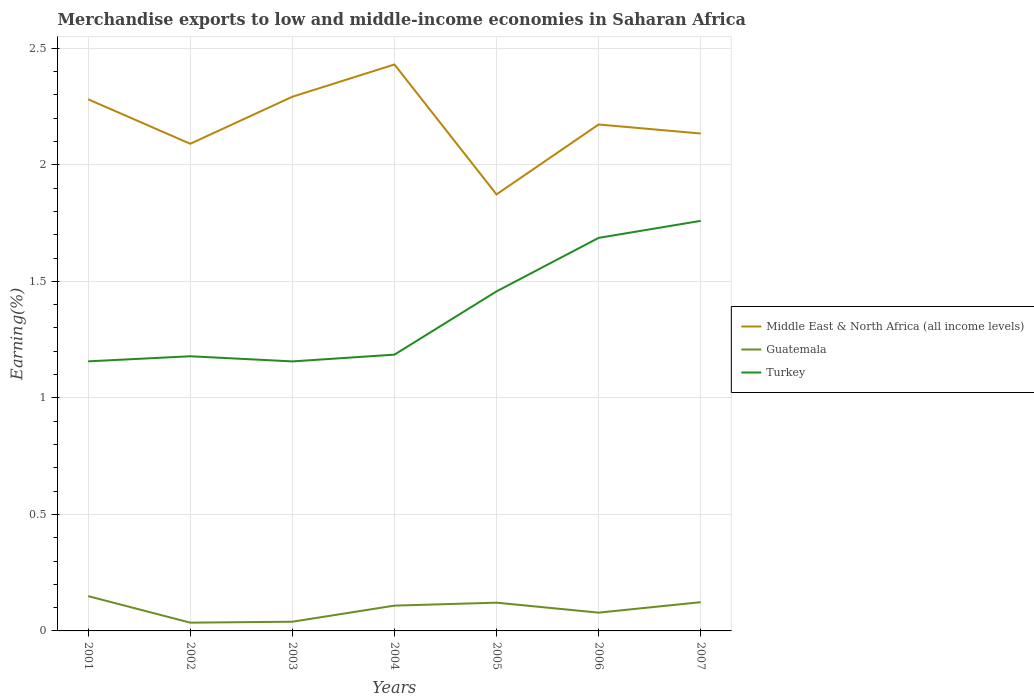Across all years, what is the maximum percentage of amount earned from merchandise exports in Guatemala?
Provide a short and direct response. 0.04. In which year was the percentage of amount earned from merchandise exports in Middle East & North Africa (all income levels) maximum?
Provide a succinct answer. 2005. What is the total percentage of amount earned from merchandise exports in Turkey in the graph?
Provide a short and direct response. 0. What is the difference between the highest and the second highest percentage of amount earned from merchandise exports in Middle East & North Africa (all income levels)?
Offer a terse response. 0.56. What is the difference between the highest and the lowest percentage of amount earned from merchandise exports in Guatemala?
Make the answer very short. 4. Is the percentage of amount earned from merchandise exports in Turkey strictly greater than the percentage of amount earned from merchandise exports in Guatemala over the years?
Your response must be concise. No. How many years are there in the graph?
Provide a succinct answer. 7. Does the graph contain any zero values?
Your response must be concise. No. What is the title of the graph?
Your answer should be very brief. Merchandise exports to low and middle-income economies in Saharan Africa. Does "Iran" appear as one of the legend labels in the graph?
Offer a very short reply. No. What is the label or title of the Y-axis?
Provide a short and direct response. Earning(%). What is the Earning(%) of Middle East & North Africa (all income levels) in 2001?
Your answer should be compact. 2.28. What is the Earning(%) in Guatemala in 2001?
Make the answer very short. 0.15. What is the Earning(%) of Turkey in 2001?
Make the answer very short. 1.16. What is the Earning(%) of Middle East & North Africa (all income levels) in 2002?
Ensure brevity in your answer.  2.09. What is the Earning(%) of Guatemala in 2002?
Make the answer very short. 0.04. What is the Earning(%) in Turkey in 2002?
Ensure brevity in your answer.  1.18. What is the Earning(%) in Middle East & North Africa (all income levels) in 2003?
Offer a terse response. 2.29. What is the Earning(%) in Guatemala in 2003?
Your answer should be compact. 0.04. What is the Earning(%) of Turkey in 2003?
Your answer should be very brief. 1.16. What is the Earning(%) in Middle East & North Africa (all income levels) in 2004?
Your response must be concise. 2.43. What is the Earning(%) in Guatemala in 2004?
Give a very brief answer. 0.11. What is the Earning(%) of Turkey in 2004?
Provide a succinct answer. 1.19. What is the Earning(%) of Middle East & North Africa (all income levels) in 2005?
Offer a terse response. 1.87. What is the Earning(%) of Guatemala in 2005?
Ensure brevity in your answer.  0.12. What is the Earning(%) of Turkey in 2005?
Give a very brief answer. 1.46. What is the Earning(%) in Middle East & North Africa (all income levels) in 2006?
Ensure brevity in your answer.  2.17. What is the Earning(%) of Guatemala in 2006?
Your answer should be compact. 0.08. What is the Earning(%) in Turkey in 2006?
Offer a very short reply. 1.69. What is the Earning(%) of Middle East & North Africa (all income levels) in 2007?
Your answer should be very brief. 2.13. What is the Earning(%) of Guatemala in 2007?
Your response must be concise. 0.12. What is the Earning(%) of Turkey in 2007?
Your answer should be very brief. 1.76. Across all years, what is the maximum Earning(%) of Middle East & North Africa (all income levels)?
Your answer should be compact. 2.43. Across all years, what is the maximum Earning(%) of Guatemala?
Give a very brief answer. 0.15. Across all years, what is the maximum Earning(%) in Turkey?
Give a very brief answer. 1.76. Across all years, what is the minimum Earning(%) of Middle East & North Africa (all income levels)?
Provide a short and direct response. 1.87. Across all years, what is the minimum Earning(%) of Guatemala?
Make the answer very short. 0.04. Across all years, what is the minimum Earning(%) in Turkey?
Your answer should be compact. 1.16. What is the total Earning(%) in Middle East & North Africa (all income levels) in the graph?
Ensure brevity in your answer.  15.27. What is the total Earning(%) in Guatemala in the graph?
Provide a succinct answer. 0.66. What is the total Earning(%) of Turkey in the graph?
Your answer should be very brief. 9.58. What is the difference between the Earning(%) in Middle East & North Africa (all income levels) in 2001 and that in 2002?
Make the answer very short. 0.19. What is the difference between the Earning(%) of Guatemala in 2001 and that in 2002?
Give a very brief answer. 0.11. What is the difference between the Earning(%) in Turkey in 2001 and that in 2002?
Keep it short and to the point. -0.02. What is the difference between the Earning(%) of Middle East & North Africa (all income levels) in 2001 and that in 2003?
Your answer should be compact. -0.01. What is the difference between the Earning(%) in Guatemala in 2001 and that in 2003?
Your response must be concise. 0.11. What is the difference between the Earning(%) in Turkey in 2001 and that in 2003?
Ensure brevity in your answer.  0. What is the difference between the Earning(%) of Middle East & North Africa (all income levels) in 2001 and that in 2004?
Make the answer very short. -0.15. What is the difference between the Earning(%) of Guatemala in 2001 and that in 2004?
Offer a very short reply. 0.04. What is the difference between the Earning(%) of Turkey in 2001 and that in 2004?
Give a very brief answer. -0.03. What is the difference between the Earning(%) of Middle East & North Africa (all income levels) in 2001 and that in 2005?
Make the answer very short. 0.41. What is the difference between the Earning(%) of Guatemala in 2001 and that in 2005?
Provide a succinct answer. 0.03. What is the difference between the Earning(%) in Turkey in 2001 and that in 2005?
Ensure brevity in your answer.  -0.3. What is the difference between the Earning(%) of Middle East & North Africa (all income levels) in 2001 and that in 2006?
Your answer should be very brief. 0.11. What is the difference between the Earning(%) in Guatemala in 2001 and that in 2006?
Provide a short and direct response. 0.07. What is the difference between the Earning(%) in Turkey in 2001 and that in 2006?
Your response must be concise. -0.53. What is the difference between the Earning(%) of Middle East & North Africa (all income levels) in 2001 and that in 2007?
Give a very brief answer. 0.15. What is the difference between the Earning(%) in Guatemala in 2001 and that in 2007?
Your response must be concise. 0.03. What is the difference between the Earning(%) in Turkey in 2001 and that in 2007?
Keep it short and to the point. -0.6. What is the difference between the Earning(%) of Middle East & North Africa (all income levels) in 2002 and that in 2003?
Provide a succinct answer. -0.2. What is the difference between the Earning(%) in Guatemala in 2002 and that in 2003?
Keep it short and to the point. -0. What is the difference between the Earning(%) in Turkey in 2002 and that in 2003?
Offer a terse response. 0.02. What is the difference between the Earning(%) of Middle East & North Africa (all income levels) in 2002 and that in 2004?
Keep it short and to the point. -0.34. What is the difference between the Earning(%) of Guatemala in 2002 and that in 2004?
Keep it short and to the point. -0.07. What is the difference between the Earning(%) in Turkey in 2002 and that in 2004?
Your response must be concise. -0.01. What is the difference between the Earning(%) of Middle East & North Africa (all income levels) in 2002 and that in 2005?
Give a very brief answer. 0.22. What is the difference between the Earning(%) of Guatemala in 2002 and that in 2005?
Keep it short and to the point. -0.09. What is the difference between the Earning(%) in Turkey in 2002 and that in 2005?
Ensure brevity in your answer.  -0.28. What is the difference between the Earning(%) in Middle East & North Africa (all income levels) in 2002 and that in 2006?
Give a very brief answer. -0.08. What is the difference between the Earning(%) of Guatemala in 2002 and that in 2006?
Your answer should be very brief. -0.04. What is the difference between the Earning(%) of Turkey in 2002 and that in 2006?
Keep it short and to the point. -0.51. What is the difference between the Earning(%) of Middle East & North Africa (all income levels) in 2002 and that in 2007?
Keep it short and to the point. -0.04. What is the difference between the Earning(%) in Guatemala in 2002 and that in 2007?
Keep it short and to the point. -0.09. What is the difference between the Earning(%) in Turkey in 2002 and that in 2007?
Provide a short and direct response. -0.58. What is the difference between the Earning(%) in Middle East & North Africa (all income levels) in 2003 and that in 2004?
Give a very brief answer. -0.14. What is the difference between the Earning(%) of Guatemala in 2003 and that in 2004?
Offer a very short reply. -0.07. What is the difference between the Earning(%) in Turkey in 2003 and that in 2004?
Give a very brief answer. -0.03. What is the difference between the Earning(%) of Middle East & North Africa (all income levels) in 2003 and that in 2005?
Provide a succinct answer. 0.42. What is the difference between the Earning(%) of Guatemala in 2003 and that in 2005?
Keep it short and to the point. -0.08. What is the difference between the Earning(%) in Turkey in 2003 and that in 2005?
Make the answer very short. -0.3. What is the difference between the Earning(%) of Middle East & North Africa (all income levels) in 2003 and that in 2006?
Make the answer very short. 0.12. What is the difference between the Earning(%) of Guatemala in 2003 and that in 2006?
Make the answer very short. -0.04. What is the difference between the Earning(%) in Turkey in 2003 and that in 2006?
Your answer should be compact. -0.53. What is the difference between the Earning(%) in Middle East & North Africa (all income levels) in 2003 and that in 2007?
Keep it short and to the point. 0.16. What is the difference between the Earning(%) in Guatemala in 2003 and that in 2007?
Keep it short and to the point. -0.08. What is the difference between the Earning(%) in Turkey in 2003 and that in 2007?
Offer a very short reply. -0.6. What is the difference between the Earning(%) of Middle East & North Africa (all income levels) in 2004 and that in 2005?
Keep it short and to the point. 0.56. What is the difference between the Earning(%) in Guatemala in 2004 and that in 2005?
Your answer should be compact. -0.01. What is the difference between the Earning(%) of Turkey in 2004 and that in 2005?
Ensure brevity in your answer.  -0.27. What is the difference between the Earning(%) of Middle East & North Africa (all income levels) in 2004 and that in 2006?
Ensure brevity in your answer.  0.26. What is the difference between the Earning(%) in Guatemala in 2004 and that in 2006?
Offer a terse response. 0.03. What is the difference between the Earning(%) in Turkey in 2004 and that in 2006?
Provide a short and direct response. -0.5. What is the difference between the Earning(%) of Middle East & North Africa (all income levels) in 2004 and that in 2007?
Ensure brevity in your answer.  0.3. What is the difference between the Earning(%) in Guatemala in 2004 and that in 2007?
Give a very brief answer. -0.01. What is the difference between the Earning(%) of Turkey in 2004 and that in 2007?
Keep it short and to the point. -0.57. What is the difference between the Earning(%) of Middle East & North Africa (all income levels) in 2005 and that in 2006?
Your response must be concise. -0.3. What is the difference between the Earning(%) in Guatemala in 2005 and that in 2006?
Offer a terse response. 0.04. What is the difference between the Earning(%) of Turkey in 2005 and that in 2006?
Provide a short and direct response. -0.23. What is the difference between the Earning(%) of Middle East & North Africa (all income levels) in 2005 and that in 2007?
Offer a terse response. -0.26. What is the difference between the Earning(%) of Guatemala in 2005 and that in 2007?
Offer a very short reply. -0. What is the difference between the Earning(%) of Turkey in 2005 and that in 2007?
Offer a terse response. -0.3. What is the difference between the Earning(%) of Middle East & North Africa (all income levels) in 2006 and that in 2007?
Keep it short and to the point. 0.04. What is the difference between the Earning(%) in Guatemala in 2006 and that in 2007?
Provide a short and direct response. -0.04. What is the difference between the Earning(%) in Turkey in 2006 and that in 2007?
Your answer should be compact. -0.07. What is the difference between the Earning(%) of Middle East & North Africa (all income levels) in 2001 and the Earning(%) of Guatemala in 2002?
Your response must be concise. 2.25. What is the difference between the Earning(%) in Middle East & North Africa (all income levels) in 2001 and the Earning(%) in Turkey in 2002?
Offer a terse response. 1.1. What is the difference between the Earning(%) of Guatemala in 2001 and the Earning(%) of Turkey in 2002?
Ensure brevity in your answer.  -1.03. What is the difference between the Earning(%) of Middle East & North Africa (all income levels) in 2001 and the Earning(%) of Guatemala in 2003?
Keep it short and to the point. 2.24. What is the difference between the Earning(%) of Middle East & North Africa (all income levels) in 2001 and the Earning(%) of Turkey in 2003?
Offer a terse response. 1.12. What is the difference between the Earning(%) in Guatemala in 2001 and the Earning(%) in Turkey in 2003?
Provide a short and direct response. -1.01. What is the difference between the Earning(%) of Middle East & North Africa (all income levels) in 2001 and the Earning(%) of Guatemala in 2004?
Give a very brief answer. 2.17. What is the difference between the Earning(%) in Middle East & North Africa (all income levels) in 2001 and the Earning(%) in Turkey in 2004?
Your answer should be compact. 1.1. What is the difference between the Earning(%) in Guatemala in 2001 and the Earning(%) in Turkey in 2004?
Offer a very short reply. -1.04. What is the difference between the Earning(%) in Middle East & North Africa (all income levels) in 2001 and the Earning(%) in Guatemala in 2005?
Provide a short and direct response. 2.16. What is the difference between the Earning(%) of Middle East & North Africa (all income levels) in 2001 and the Earning(%) of Turkey in 2005?
Offer a very short reply. 0.82. What is the difference between the Earning(%) of Guatemala in 2001 and the Earning(%) of Turkey in 2005?
Your answer should be compact. -1.31. What is the difference between the Earning(%) of Middle East & North Africa (all income levels) in 2001 and the Earning(%) of Guatemala in 2006?
Make the answer very short. 2.2. What is the difference between the Earning(%) in Middle East & North Africa (all income levels) in 2001 and the Earning(%) in Turkey in 2006?
Your answer should be compact. 0.59. What is the difference between the Earning(%) in Guatemala in 2001 and the Earning(%) in Turkey in 2006?
Ensure brevity in your answer.  -1.54. What is the difference between the Earning(%) in Middle East & North Africa (all income levels) in 2001 and the Earning(%) in Guatemala in 2007?
Give a very brief answer. 2.16. What is the difference between the Earning(%) of Middle East & North Africa (all income levels) in 2001 and the Earning(%) of Turkey in 2007?
Your response must be concise. 0.52. What is the difference between the Earning(%) in Guatemala in 2001 and the Earning(%) in Turkey in 2007?
Offer a very short reply. -1.61. What is the difference between the Earning(%) in Middle East & North Africa (all income levels) in 2002 and the Earning(%) in Guatemala in 2003?
Offer a very short reply. 2.05. What is the difference between the Earning(%) of Middle East & North Africa (all income levels) in 2002 and the Earning(%) of Turkey in 2003?
Give a very brief answer. 0.93. What is the difference between the Earning(%) of Guatemala in 2002 and the Earning(%) of Turkey in 2003?
Provide a short and direct response. -1.12. What is the difference between the Earning(%) of Middle East & North Africa (all income levels) in 2002 and the Earning(%) of Guatemala in 2004?
Make the answer very short. 1.98. What is the difference between the Earning(%) in Middle East & North Africa (all income levels) in 2002 and the Earning(%) in Turkey in 2004?
Provide a succinct answer. 0.9. What is the difference between the Earning(%) of Guatemala in 2002 and the Earning(%) of Turkey in 2004?
Keep it short and to the point. -1.15. What is the difference between the Earning(%) of Middle East & North Africa (all income levels) in 2002 and the Earning(%) of Guatemala in 2005?
Your response must be concise. 1.97. What is the difference between the Earning(%) of Middle East & North Africa (all income levels) in 2002 and the Earning(%) of Turkey in 2005?
Offer a terse response. 0.63. What is the difference between the Earning(%) of Guatemala in 2002 and the Earning(%) of Turkey in 2005?
Ensure brevity in your answer.  -1.42. What is the difference between the Earning(%) of Middle East & North Africa (all income levels) in 2002 and the Earning(%) of Guatemala in 2006?
Make the answer very short. 2.01. What is the difference between the Earning(%) in Middle East & North Africa (all income levels) in 2002 and the Earning(%) in Turkey in 2006?
Your answer should be very brief. 0.4. What is the difference between the Earning(%) in Guatemala in 2002 and the Earning(%) in Turkey in 2006?
Keep it short and to the point. -1.65. What is the difference between the Earning(%) of Middle East & North Africa (all income levels) in 2002 and the Earning(%) of Guatemala in 2007?
Provide a short and direct response. 1.97. What is the difference between the Earning(%) in Middle East & North Africa (all income levels) in 2002 and the Earning(%) in Turkey in 2007?
Offer a very short reply. 0.33. What is the difference between the Earning(%) of Guatemala in 2002 and the Earning(%) of Turkey in 2007?
Your answer should be very brief. -1.72. What is the difference between the Earning(%) of Middle East & North Africa (all income levels) in 2003 and the Earning(%) of Guatemala in 2004?
Your response must be concise. 2.18. What is the difference between the Earning(%) of Middle East & North Africa (all income levels) in 2003 and the Earning(%) of Turkey in 2004?
Ensure brevity in your answer.  1.11. What is the difference between the Earning(%) of Guatemala in 2003 and the Earning(%) of Turkey in 2004?
Offer a very short reply. -1.15. What is the difference between the Earning(%) in Middle East & North Africa (all income levels) in 2003 and the Earning(%) in Guatemala in 2005?
Offer a terse response. 2.17. What is the difference between the Earning(%) of Middle East & North Africa (all income levels) in 2003 and the Earning(%) of Turkey in 2005?
Offer a very short reply. 0.84. What is the difference between the Earning(%) of Guatemala in 2003 and the Earning(%) of Turkey in 2005?
Your answer should be compact. -1.42. What is the difference between the Earning(%) of Middle East & North Africa (all income levels) in 2003 and the Earning(%) of Guatemala in 2006?
Offer a very short reply. 2.21. What is the difference between the Earning(%) of Middle East & North Africa (all income levels) in 2003 and the Earning(%) of Turkey in 2006?
Your answer should be compact. 0.61. What is the difference between the Earning(%) of Guatemala in 2003 and the Earning(%) of Turkey in 2006?
Provide a short and direct response. -1.65. What is the difference between the Earning(%) in Middle East & North Africa (all income levels) in 2003 and the Earning(%) in Guatemala in 2007?
Your answer should be compact. 2.17. What is the difference between the Earning(%) in Middle East & North Africa (all income levels) in 2003 and the Earning(%) in Turkey in 2007?
Ensure brevity in your answer.  0.53. What is the difference between the Earning(%) in Guatemala in 2003 and the Earning(%) in Turkey in 2007?
Offer a very short reply. -1.72. What is the difference between the Earning(%) in Middle East & North Africa (all income levels) in 2004 and the Earning(%) in Guatemala in 2005?
Provide a succinct answer. 2.31. What is the difference between the Earning(%) in Middle East & North Africa (all income levels) in 2004 and the Earning(%) in Turkey in 2005?
Make the answer very short. 0.97. What is the difference between the Earning(%) in Guatemala in 2004 and the Earning(%) in Turkey in 2005?
Keep it short and to the point. -1.35. What is the difference between the Earning(%) of Middle East & North Africa (all income levels) in 2004 and the Earning(%) of Guatemala in 2006?
Keep it short and to the point. 2.35. What is the difference between the Earning(%) in Middle East & North Africa (all income levels) in 2004 and the Earning(%) in Turkey in 2006?
Provide a succinct answer. 0.74. What is the difference between the Earning(%) of Guatemala in 2004 and the Earning(%) of Turkey in 2006?
Ensure brevity in your answer.  -1.58. What is the difference between the Earning(%) in Middle East & North Africa (all income levels) in 2004 and the Earning(%) in Guatemala in 2007?
Provide a succinct answer. 2.31. What is the difference between the Earning(%) in Middle East & North Africa (all income levels) in 2004 and the Earning(%) in Turkey in 2007?
Your answer should be very brief. 0.67. What is the difference between the Earning(%) in Guatemala in 2004 and the Earning(%) in Turkey in 2007?
Your answer should be compact. -1.65. What is the difference between the Earning(%) in Middle East & North Africa (all income levels) in 2005 and the Earning(%) in Guatemala in 2006?
Give a very brief answer. 1.79. What is the difference between the Earning(%) in Middle East & North Africa (all income levels) in 2005 and the Earning(%) in Turkey in 2006?
Your answer should be very brief. 0.19. What is the difference between the Earning(%) of Guatemala in 2005 and the Earning(%) of Turkey in 2006?
Offer a terse response. -1.57. What is the difference between the Earning(%) in Middle East & North Africa (all income levels) in 2005 and the Earning(%) in Guatemala in 2007?
Keep it short and to the point. 1.75. What is the difference between the Earning(%) of Middle East & North Africa (all income levels) in 2005 and the Earning(%) of Turkey in 2007?
Ensure brevity in your answer.  0.11. What is the difference between the Earning(%) of Guatemala in 2005 and the Earning(%) of Turkey in 2007?
Ensure brevity in your answer.  -1.64. What is the difference between the Earning(%) in Middle East & North Africa (all income levels) in 2006 and the Earning(%) in Guatemala in 2007?
Offer a terse response. 2.05. What is the difference between the Earning(%) of Middle East & North Africa (all income levels) in 2006 and the Earning(%) of Turkey in 2007?
Offer a very short reply. 0.41. What is the difference between the Earning(%) in Guatemala in 2006 and the Earning(%) in Turkey in 2007?
Offer a very short reply. -1.68. What is the average Earning(%) of Middle East & North Africa (all income levels) per year?
Make the answer very short. 2.18. What is the average Earning(%) in Guatemala per year?
Make the answer very short. 0.09. What is the average Earning(%) of Turkey per year?
Provide a succinct answer. 1.37. In the year 2001, what is the difference between the Earning(%) in Middle East & North Africa (all income levels) and Earning(%) in Guatemala?
Your response must be concise. 2.13. In the year 2001, what is the difference between the Earning(%) in Middle East & North Africa (all income levels) and Earning(%) in Turkey?
Offer a terse response. 1.12. In the year 2001, what is the difference between the Earning(%) in Guatemala and Earning(%) in Turkey?
Ensure brevity in your answer.  -1.01. In the year 2002, what is the difference between the Earning(%) in Middle East & North Africa (all income levels) and Earning(%) in Guatemala?
Your answer should be very brief. 2.05. In the year 2002, what is the difference between the Earning(%) in Middle East & North Africa (all income levels) and Earning(%) in Turkey?
Your answer should be very brief. 0.91. In the year 2002, what is the difference between the Earning(%) of Guatemala and Earning(%) of Turkey?
Give a very brief answer. -1.14. In the year 2003, what is the difference between the Earning(%) of Middle East & North Africa (all income levels) and Earning(%) of Guatemala?
Offer a very short reply. 2.25. In the year 2003, what is the difference between the Earning(%) of Middle East & North Africa (all income levels) and Earning(%) of Turkey?
Provide a short and direct response. 1.14. In the year 2003, what is the difference between the Earning(%) in Guatemala and Earning(%) in Turkey?
Offer a terse response. -1.12. In the year 2004, what is the difference between the Earning(%) of Middle East & North Africa (all income levels) and Earning(%) of Guatemala?
Provide a succinct answer. 2.32. In the year 2004, what is the difference between the Earning(%) of Middle East & North Africa (all income levels) and Earning(%) of Turkey?
Provide a succinct answer. 1.25. In the year 2004, what is the difference between the Earning(%) in Guatemala and Earning(%) in Turkey?
Provide a succinct answer. -1.08. In the year 2005, what is the difference between the Earning(%) in Middle East & North Africa (all income levels) and Earning(%) in Guatemala?
Your response must be concise. 1.75. In the year 2005, what is the difference between the Earning(%) of Middle East & North Africa (all income levels) and Earning(%) of Turkey?
Keep it short and to the point. 0.42. In the year 2005, what is the difference between the Earning(%) of Guatemala and Earning(%) of Turkey?
Your response must be concise. -1.34. In the year 2006, what is the difference between the Earning(%) of Middle East & North Africa (all income levels) and Earning(%) of Guatemala?
Ensure brevity in your answer.  2.09. In the year 2006, what is the difference between the Earning(%) in Middle East & North Africa (all income levels) and Earning(%) in Turkey?
Give a very brief answer. 0.49. In the year 2006, what is the difference between the Earning(%) of Guatemala and Earning(%) of Turkey?
Provide a short and direct response. -1.61. In the year 2007, what is the difference between the Earning(%) in Middle East & North Africa (all income levels) and Earning(%) in Guatemala?
Your answer should be very brief. 2.01. In the year 2007, what is the difference between the Earning(%) in Middle East & North Africa (all income levels) and Earning(%) in Turkey?
Your answer should be compact. 0.37. In the year 2007, what is the difference between the Earning(%) of Guatemala and Earning(%) of Turkey?
Give a very brief answer. -1.64. What is the ratio of the Earning(%) in Middle East & North Africa (all income levels) in 2001 to that in 2002?
Keep it short and to the point. 1.09. What is the ratio of the Earning(%) of Guatemala in 2001 to that in 2002?
Provide a succinct answer. 4.21. What is the ratio of the Earning(%) in Turkey in 2001 to that in 2002?
Give a very brief answer. 0.98. What is the ratio of the Earning(%) in Guatemala in 2001 to that in 2003?
Give a very brief answer. 3.78. What is the ratio of the Earning(%) of Turkey in 2001 to that in 2003?
Provide a succinct answer. 1. What is the ratio of the Earning(%) of Middle East & North Africa (all income levels) in 2001 to that in 2004?
Your answer should be very brief. 0.94. What is the ratio of the Earning(%) in Guatemala in 2001 to that in 2004?
Make the answer very short. 1.38. What is the ratio of the Earning(%) of Turkey in 2001 to that in 2004?
Offer a terse response. 0.98. What is the ratio of the Earning(%) in Middle East & North Africa (all income levels) in 2001 to that in 2005?
Keep it short and to the point. 1.22. What is the ratio of the Earning(%) of Guatemala in 2001 to that in 2005?
Keep it short and to the point. 1.23. What is the ratio of the Earning(%) of Turkey in 2001 to that in 2005?
Make the answer very short. 0.79. What is the ratio of the Earning(%) of Middle East & North Africa (all income levels) in 2001 to that in 2006?
Offer a terse response. 1.05. What is the ratio of the Earning(%) in Guatemala in 2001 to that in 2006?
Offer a terse response. 1.9. What is the ratio of the Earning(%) in Turkey in 2001 to that in 2006?
Offer a very short reply. 0.69. What is the ratio of the Earning(%) of Middle East & North Africa (all income levels) in 2001 to that in 2007?
Your response must be concise. 1.07. What is the ratio of the Earning(%) of Guatemala in 2001 to that in 2007?
Offer a terse response. 1.21. What is the ratio of the Earning(%) in Turkey in 2001 to that in 2007?
Keep it short and to the point. 0.66. What is the ratio of the Earning(%) of Middle East & North Africa (all income levels) in 2002 to that in 2003?
Ensure brevity in your answer.  0.91. What is the ratio of the Earning(%) in Guatemala in 2002 to that in 2003?
Your answer should be compact. 0.9. What is the ratio of the Earning(%) in Turkey in 2002 to that in 2003?
Ensure brevity in your answer.  1.02. What is the ratio of the Earning(%) of Middle East & North Africa (all income levels) in 2002 to that in 2004?
Your response must be concise. 0.86. What is the ratio of the Earning(%) of Guatemala in 2002 to that in 2004?
Keep it short and to the point. 0.33. What is the ratio of the Earning(%) in Middle East & North Africa (all income levels) in 2002 to that in 2005?
Offer a very short reply. 1.12. What is the ratio of the Earning(%) of Guatemala in 2002 to that in 2005?
Offer a very short reply. 0.29. What is the ratio of the Earning(%) of Turkey in 2002 to that in 2005?
Keep it short and to the point. 0.81. What is the ratio of the Earning(%) in Middle East & North Africa (all income levels) in 2002 to that in 2006?
Provide a short and direct response. 0.96. What is the ratio of the Earning(%) of Guatemala in 2002 to that in 2006?
Your response must be concise. 0.45. What is the ratio of the Earning(%) of Turkey in 2002 to that in 2006?
Offer a very short reply. 0.7. What is the ratio of the Earning(%) of Middle East & North Africa (all income levels) in 2002 to that in 2007?
Your answer should be compact. 0.98. What is the ratio of the Earning(%) of Guatemala in 2002 to that in 2007?
Offer a very short reply. 0.29. What is the ratio of the Earning(%) of Turkey in 2002 to that in 2007?
Give a very brief answer. 0.67. What is the ratio of the Earning(%) of Middle East & North Africa (all income levels) in 2003 to that in 2004?
Your response must be concise. 0.94. What is the ratio of the Earning(%) in Guatemala in 2003 to that in 2004?
Your answer should be compact. 0.36. What is the ratio of the Earning(%) of Turkey in 2003 to that in 2004?
Your response must be concise. 0.98. What is the ratio of the Earning(%) in Middle East & North Africa (all income levels) in 2003 to that in 2005?
Offer a terse response. 1.22. What is the ratio of the Earning(%) of Guatemala in 2003 to that in 2005?
Give a very brief answer. 0.33. What is the ratio of the Earning(%) in Turkey in 2003 to that in 2005?
Your answer should be very brief. 0.79. What is the ratio of the Earning(%) in Middle East & North Africa (all income levels) in 2003 to that in 2006?
Provide a short and direct response. 1.05. What is the ratio of the Earning(%) in Guatemala in 2003 to that in 2006?
Offer a terse response. 0.5. What is the ratio of the Earning(%) in Turkey in 2003 to that in 2006?
Provide a succinct answer. 0.69. What is the ratio of the Earning(%) in Middle East & North Africa (all income levels) in 2003 to that in 2007?
Provide a short and direct response. 1.07. What is the ratio of the Earning(%) in Guatemala in 2003 to that in 2007?
Provide a short and direct response. 0.32. What is the ratio of the Earning(%) of Turkey in 2003 to that in 2007?
Provide a short and direct response. 0.66. What is the ratio of the Earning(%) in Middle East & North Africa (all income levels) in 2004 to that in 2005?
Offer a terse response. 1.3. What is the ratio of the Earning(%) in Guatemala in 2004 to that in 2005?
Offer a terse response. 0.9. What is the ratio of the Earning(%) of Turkey in 2004 to that in 2005?
Your answer should be compact. 0.81. What is the ratio of the Earning(%) of Middle East & North Africa (all income levels) in 2004 to that in 2006?
Provide a succinct answer. 1.12. What is the ratio of the Earning(%) in Guatemala in 2004 to that in 2006?
Provide a succinct answer. 1.38. What is the ratio of the Earning(%) of Turkey in 2004 to that in 2006?
Provide a succinct answer. 0.7. What is the ratio of the Earning(%) in Middle East & North Africa (all income levels) in 2004 to that in 2007?
Offer a terse response. 1.14. What is the ratio of the Earning(%) of Guatemala in 2004 to that in 2007?
Offer a terse response. 0.88. What is the ratio of the Earning(%) in Turkey in 2004 to that in 2007?
Give a very brief answer. 0.67. What is the ratio of the Earning(%) of Middle East & North Africa (all income levels) in 2005 to that in 2006?
Your answer should be very brief. 0.86. What is the ratio of the Earning(%) in Guatemala in 2005 to that in 2006?
Offer a very short reply. 1.55. What is the ratio of the Earning(%) of Turkey in 2005 to that in 2006?
Your answer should be very brief. 0.86. What is the ratio of the Earning(%) of Middle East & North Africa (all income levels) in 2005 to that in 2007?
Your response must be concise. 0.88. What is the ratio of the Earning(%) of Guatemala in 2005 to that in 2007?
Offer a terse response. 0.98. What is the ratio of the Earning(%) in Turkey in 2005 to that in 2007?
Provide a short and direct response. 0.83. What is the ratio of the Earning(%) of Middle East & North Africa (all income levels) in 2006 to that in 2007?
Give a very brief answer. 1.02. What is the ratio of the Earning(%) of Guatemala in 2006 to that in 2007?
Your answer should be compact. 0.64. What is the ratio of the Earning(%) of Turkey in 2006 to that in 2007?
Your answer should be compact. 0.96. What is the difference between the highest and the second highest Earning(%) of Middle East & North Africa (all income levels)?
Make the answer very short. 0.14. What is the difference between the highest and the second highest Earning(%) in Guatemala?
Give a very brief answer. 0.03. What is the difference between the highest and the second highest Earning(%) in Turkey?
Offer a very short reply. 0.07. What is the difference between the highest and the lowest Earning(%) in Middle East & North Africa (all income levels)?
Provide a short and direct response. 0.56. What is the difference between the highest and the lowest Earning(%) in Guatemala?
Offer a terse response. 0.11. What is the difference between the highest and the lowest Earning(%) of Turkey?
Offer a very short reply. 0.6. 